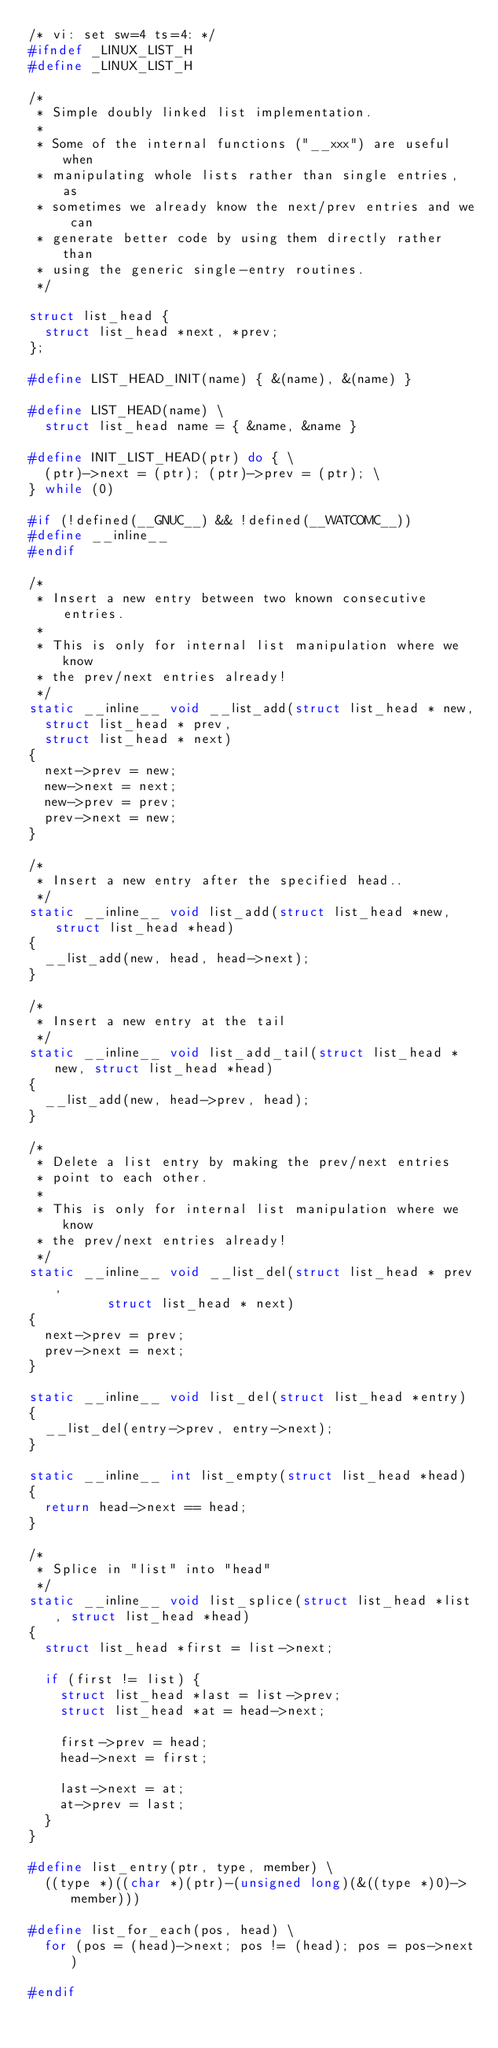<code> <loc_0><loc_0><loc_500><loc_500><_C_>/* vi: set sw=4 ts=4: */
#ifndef _LINUX_LIST_H
#define _LINUX_LIST_H

/*
 * Simple doubly linked list implementation.
 *
 * Some of the internal functions ("__xxx") are useful when
 * manipulating whole lists rather than single entries, as
 * sometimes we already know the next/prev entries and we can
 * generate better code by using them directly rather than
 * using the generic single-entry routines.
 */

struct list_head {
	struct list_head *next, *prev;
};

#define LIST_HEAD_INIT(name) { &(name), &(name) }

#define LIST_HEAD(name) \
	struct list_head name = { &name, &name }

#define INIT_LIST_HEAD(ptr) do { \
	(ptr)->next = (ptr); (ptr)->prev = (ptr); \
} while (0)

#if (!defined(__GNUC__) && !defined(__WATCOMC__))
#define __inline__
#endif

/*
 * Insert a new entry between two known consecutive entries.
 *
 * This is only for internal list manipulation where we know
 * the prev/next entries already!
 */
static __inline__ void __list_add(struct list_head * new,
	struct list_head * prev,
	struct list_head * next)
{
	next->prev = new;
	new->next = next;
	new->prev = prev;
	prev->next = new;
}

/*
 * Insert a new entry after the specified head..
 */
static __inline__ void list_add(struct list_head *new, struct list_head *head)
{
	__list_add(new, head, head->next);
}

/*
 * Insert a new entry at the tail
 */
static __inline__ void list_add_tail(struct list_head *new, struct list_head *head)
{
	__list_add(new, head->prev, head);
}

/*
 * Delete a list entry by making the prev/next entries
 * point to each other.
 *
 * This is only for internal list manipulation where we know
 * the prev/next entries already!
 */
static __inline__ void __list_del(struct list_head * prev,
				  struct list_head * next)
{
	next->prev = prev;
	prev->next = next;
}

static __inline__ void list_del(struct list_head *entry)
{
	__list_del(entry->prev, entry->next);
}

static __inline__ int list_empty(struct list_head *head)
{
	return head->next == head;
}

/*
 * Splice in "list" into "head"
 */
static __inline__ void list_splice(struct list_head *list, struct list_head *head)
{
	struct list_head *first = list->next;

	if (first != list) {
		struct list_head *last = list->prev;
		struct list_head *at = head->next;

		first->prev = head;
		head->next = first;

		last->next = at;
		at->prev = last;
	}
}

#define list_entry(ptr, type, member) \
	((type *)((char *)(ptr)-(unsigned long)(&((type *)0)->member)))

#define list_for_each(pos, head) \
	for (pos = (head)->next; pos != (head); pos = pos->next)

#endif
</code> 